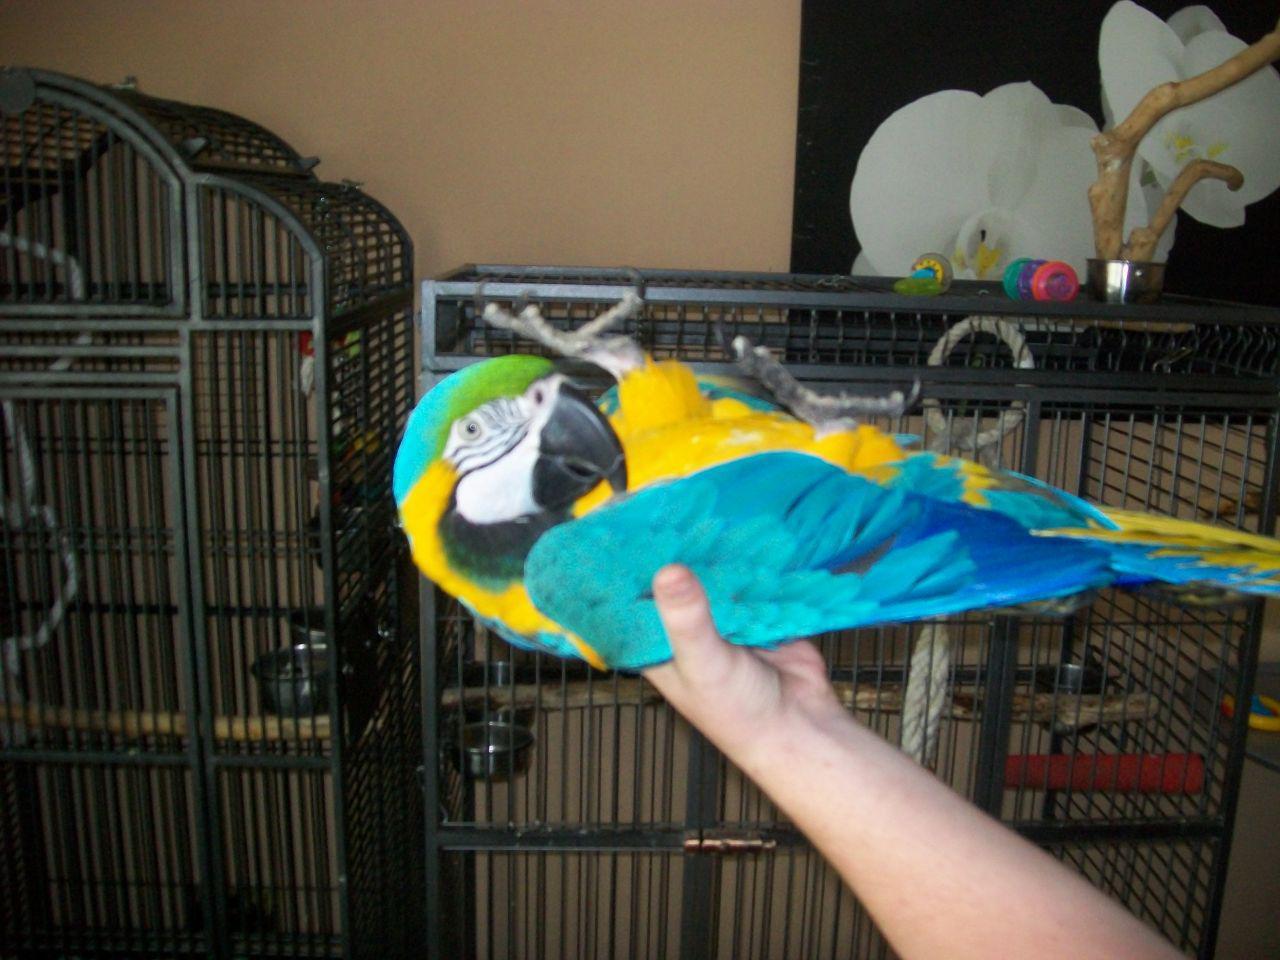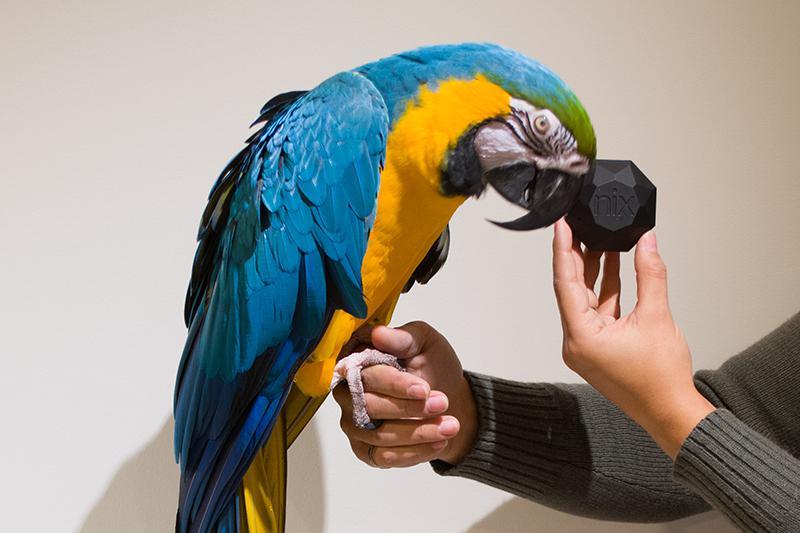The first image is the image on the left, the second image is the image on the right. Given the left and right images, does the statement "A person in long dark sleeves holds a hand near the beak of a perching blue-and-yellow parrot, in one image." hold true? Answer yes or no. Yes. The first image is the image on the left, the second image is the image on the right. Considering the images on both sides, is "One of the humans visible is wearing a long-sleeved shirt." valid? Answer yes or no. Yes. 